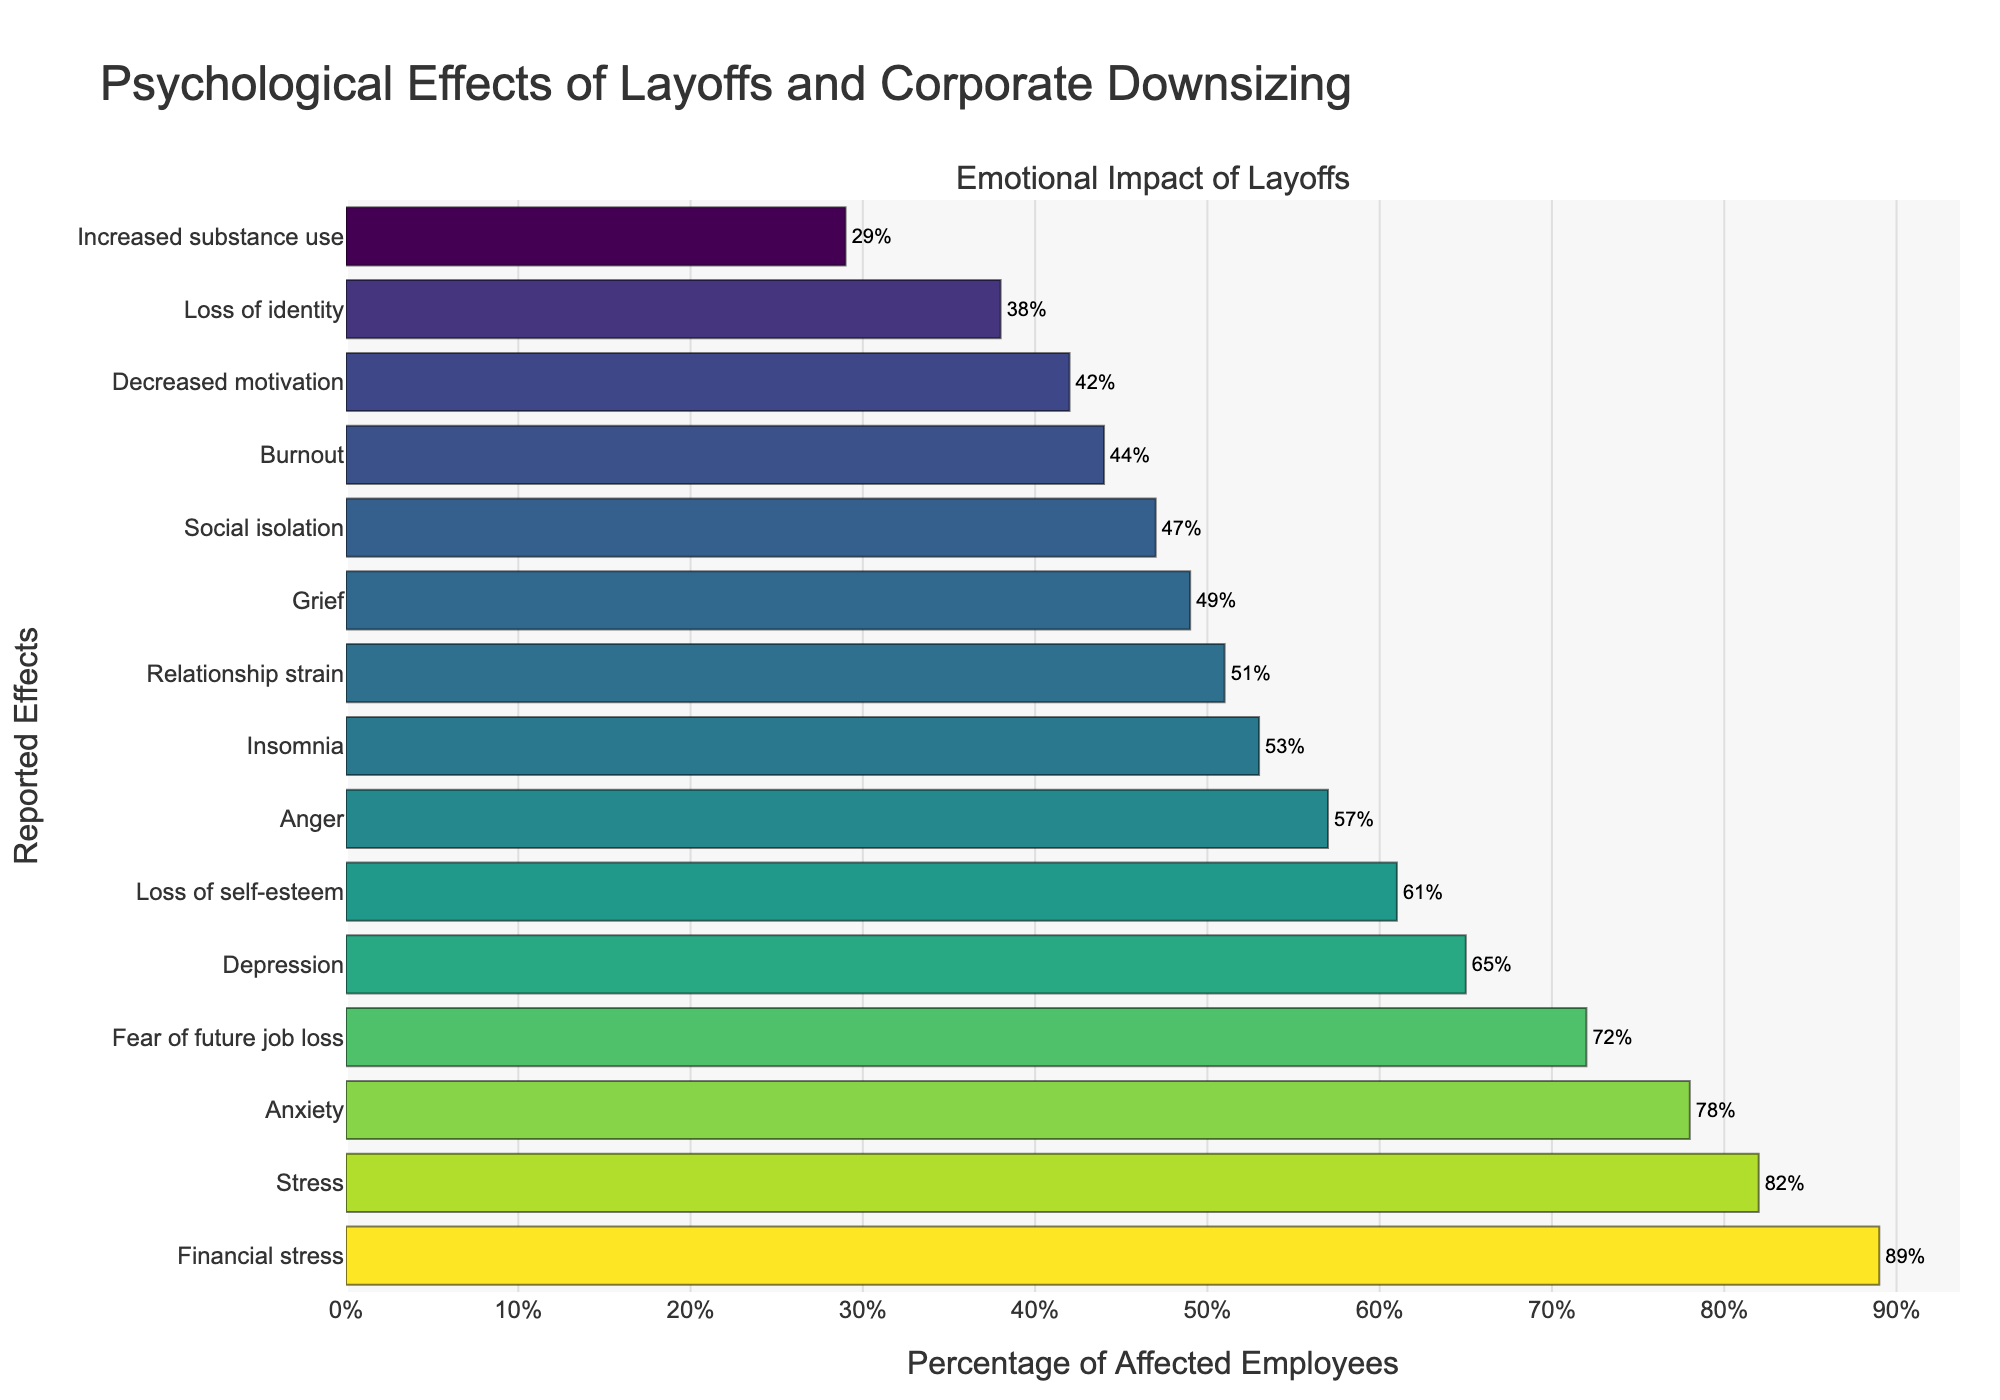Which psychological effect has the highest reported percentage of impact due to layoffs? The bar with the highest value corresponds to "Financial stress" at 89%.
Answer: Financial stress Which psychological impact is more prevalent: anxiety or depression? By comparing the bars for "Anxiety" (78%) and "Depression" (65%), anxiety has a higher percentage.
Answer: Anxiety What is the combined percentage of employees reporting stress and fear of future job loss due to layoffs? Add the percentages for "Stress" (82%) and "Fear of future job loss" (72%): 82 + 72 = 154.
Answer: 154% Which impact is less reported: social isolation or insomnia? Compare "Social isolation" (47%) and "Insomnia" (53%). Social isolation is less reported.
Answer: Social isolation Among the given effects, which one has the smallest reported percentage? The smallest bar corresponds to "Increased substance use" at 29%.
Answer: Increased substance use Calculate the average percentage impact for the top three reported effects. The top three effects are "Financial stress" (89%), "Stress" (82%), and "Anxiety" (78%). Calculate the average (89 + 82 + 78) / 3 = 83.
Answer: 83% How does the percentage of anger compare to the percentage of loss of self-esteem? "Anger" is reported at 57%, while "Loss of self-esteem" is at 61%. Loss of self-esteem is higher.
Answer: Loss of self-esteem What is the difference in the percentage between grief and burnout due to layoffs? Subtract the percentages for "Burnout" (44%) from "Grief" (49%): 49 - 44 = 5.
Answer: 5% Which effect falls exactly between loss of identity and relationship strain in terms of reported percentage? "Loss of identity" at 38% and "Relationship strain" at 51% have "Grief" (49%) and "Insomnia" (53%) around them. The closer one is "Grief" (49%).
Answer: Grief 